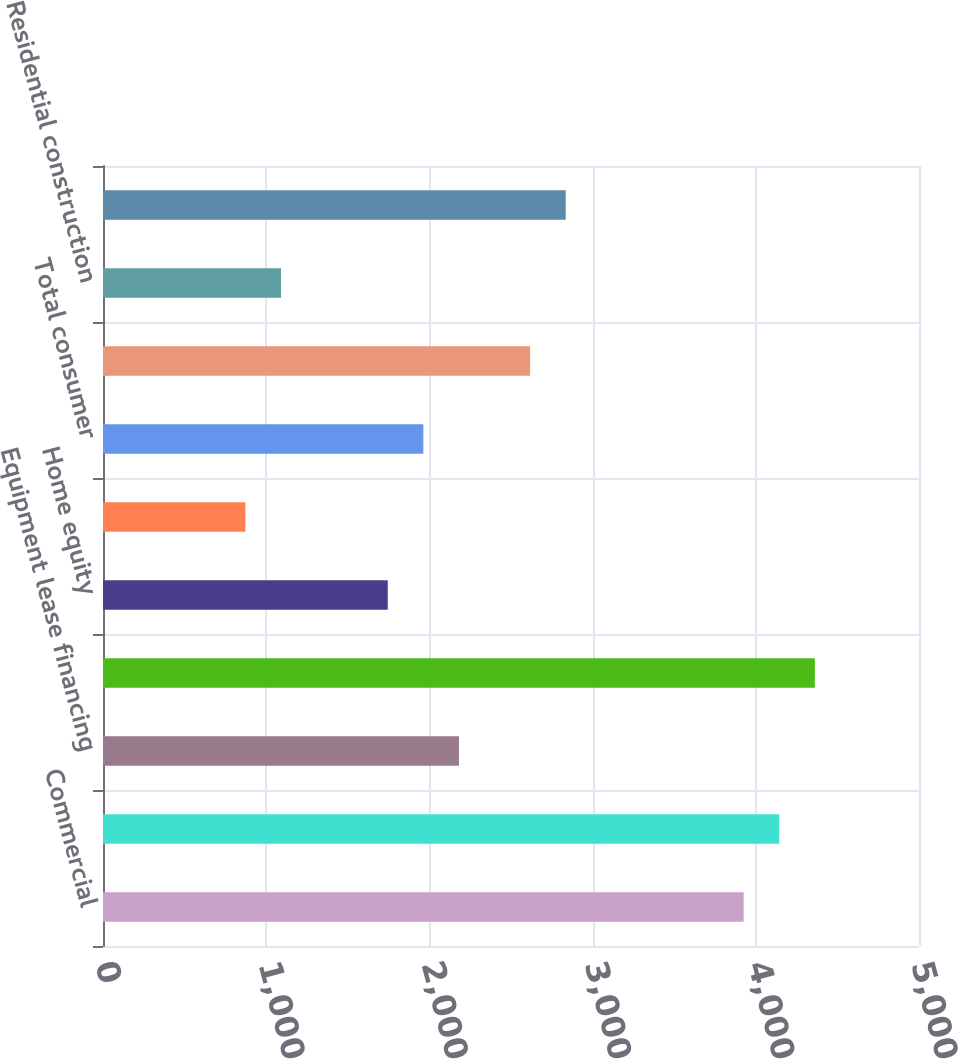Convert chart to OTSL. <chart><loc_0><loc_0><loc_500><loc_500><bar_chart><fcel>Commercial<fcel>Commercial real estate<fcel>Equipment lease financing<fcel>TOTAL COMMERCIAL LENDING<fcel>Home equity<fcel>Other<fcel>Total consumer<fcel>Residential mortgage<fcel>Residential construction<fcel>Total residential real estate<nl><fcel>3925.68<fcel>4143.76<fcel>2181.04<fcel>4361.84<fcel>1744.88<fcel>872.56<fcel>1962.96<fcel>2617.2<fcel>1090.64<fcel>2835.28<nl></chart> 